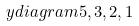Convert formula to latex. <formula><loc_0><loc_0><loc_500><loc_500>\ y d i a g r a m { 5 , 3 , 2 , 1 }</formula> 